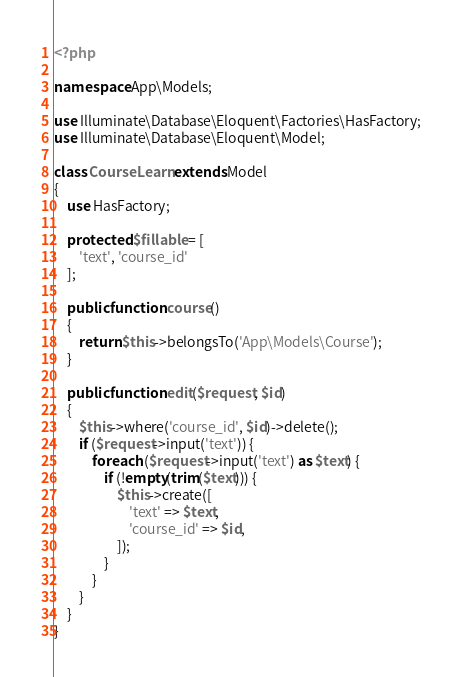Convert code to text. <code><loc_0><loc_0><loc_500><loc_500><_PHP_><?php

namespace App\Models;

use Illuminate\Database\Eloquent\Factories\HasFactory;
use Illuminate\Database\Eloquent\Model;

class CourseLearn extends Model
{
    use HasFactory;

    protected $fillable = [
        'text', 'course_id'
    ];

    public function course()
    {
        return $this->belongsTo('App\Models\Course');
    }

    public function edit($request, $id)
    {
        $this->where('course_id', $id)->delete();
        if ($request->input('text')) {
            foreach ($request->input('text') as $text) {
                if (!empty(trim($text))) {
                    $this->create([
                        'text' => $text,
                        'course_id' => $id,
                    ]);
                }
            }
        }
    }
}
</code> 